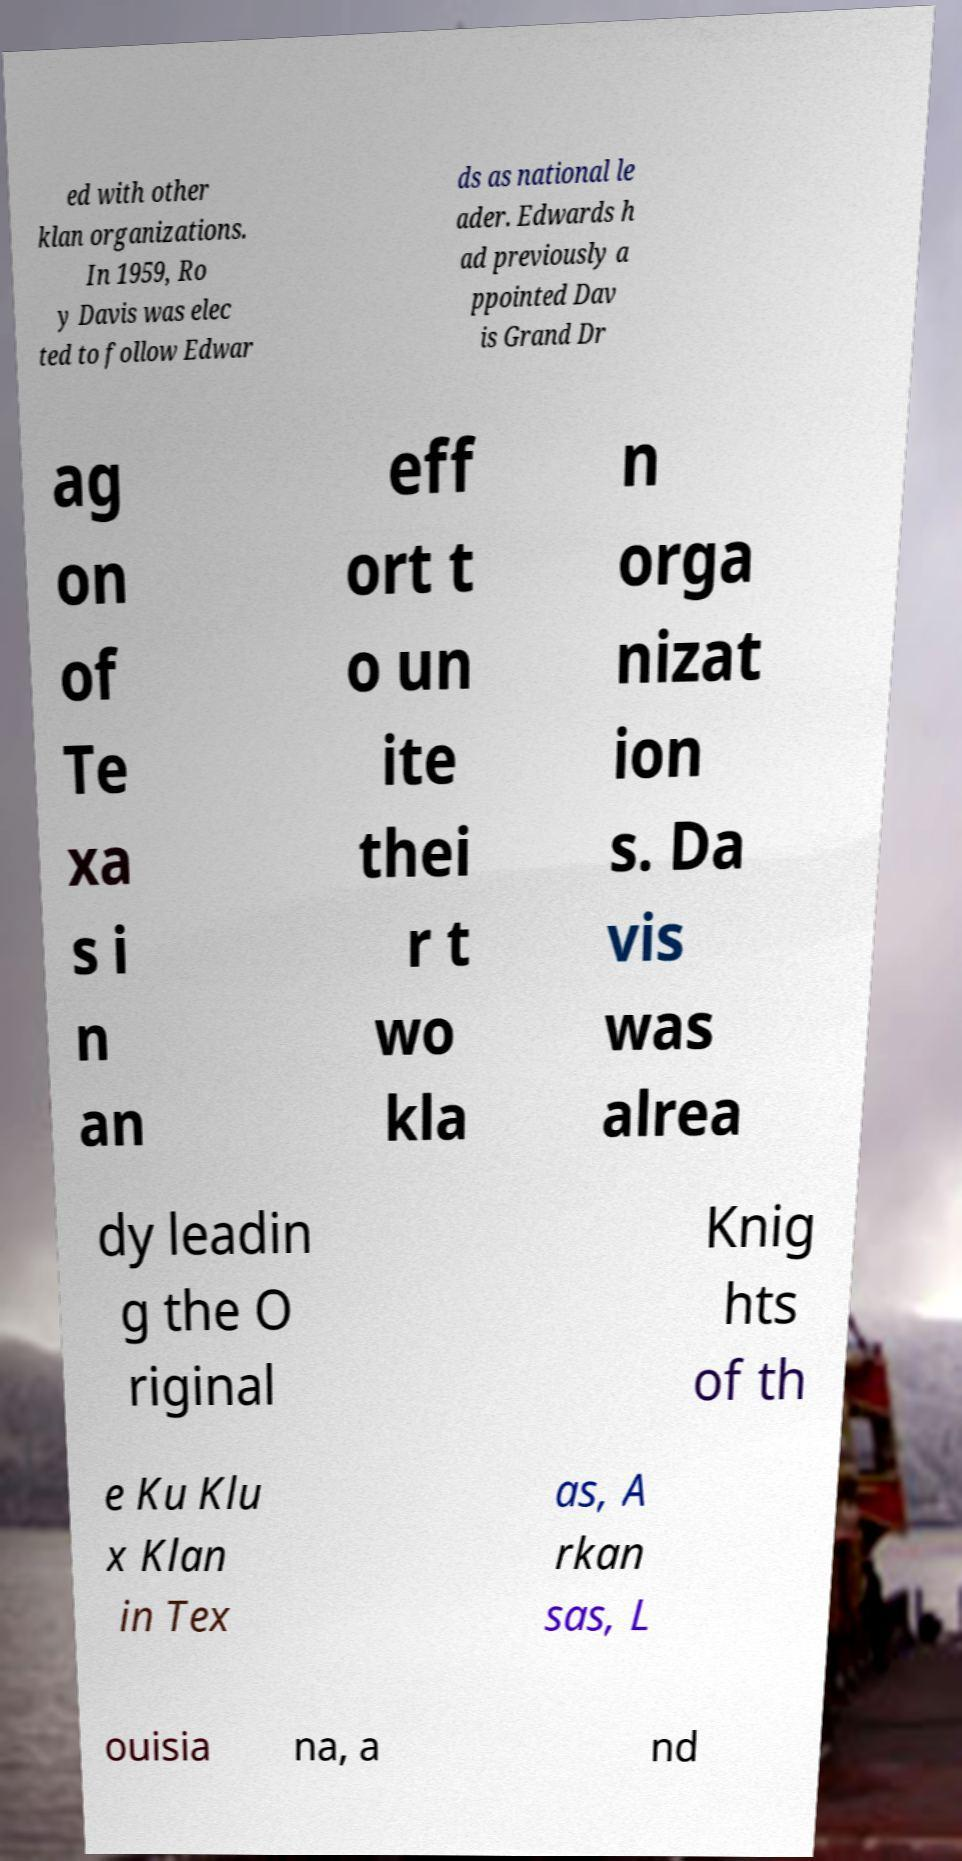Please identify and transcribe the text found in this image. ed with other klan organizations. In 1959, Ro y Davis was elec ted to follow Edwar ds as national le ader. Edwards h ad previously a ppointed Dav is Grand Dr ag on of Te xa s i n an eff ort t o un ite thei r t wo kla n orga nizat ion s. Da vis was alrea dy leadin g the O riginal Knig hts of th e Ku Klu x Klan in Tex as, A rkan sas, L ouisia na, a nd 